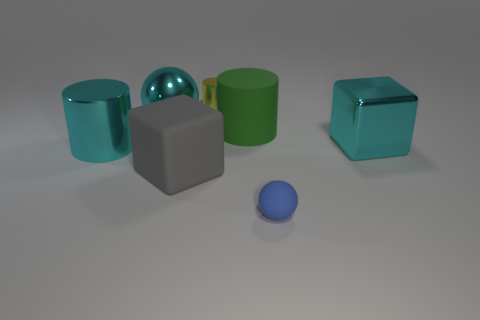Subtract all big green rubber cylinders. How many cylinders are left? 2 Add 2 matte cylinders. How many objects exist? 9 Subtract all balls. How many objects are left? 5 Add 4 yellow cubes. How many yellow cubes exist? 4 Subtract 0 blue cylinders. How many objects are left? 7 Subtract all tiny shiny cylinders. Subtract all large purple shiny spheres. How many objects are left? 6 Add 7 blue matte balls. How many blue matte balls are left? 8 